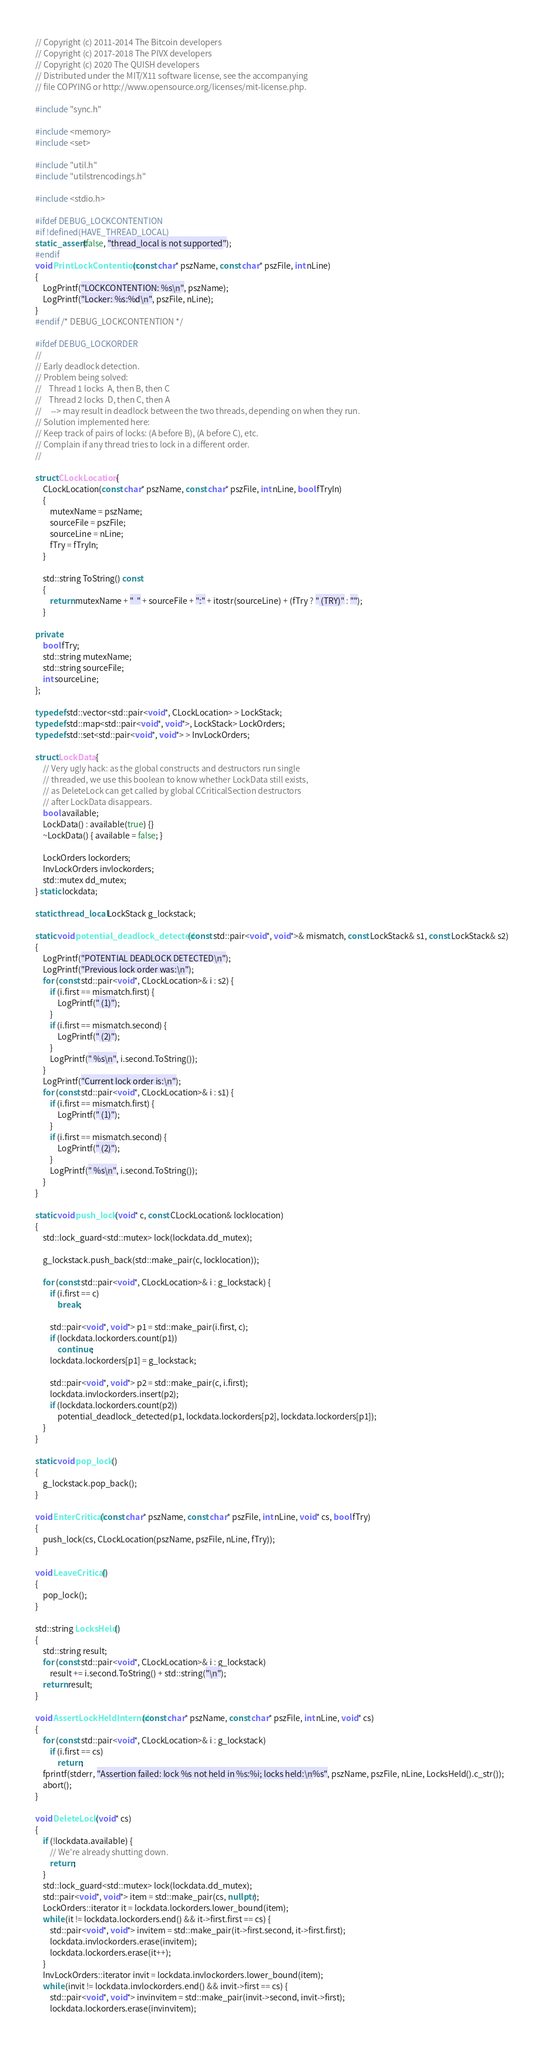<code> <loc_0><loc_0><loc_500><loc_500><_C++_>// Copyright (c) 2011-2014 The Bitcoin developers
// Copyright (c) 2017-2018 The PIVX developers
// Copyright (c) 2020 The QUISH developers
// Distributed under the MIT/X11 software license, see the accompanying
// file COPYING or http://www.opensource.org/licenses/mit-license.php.

#include "sync.h"

#include <memory>
#include <set>

#include "util.h"
#include "utilstrencodings.h"

#include <stdio.h>

#ifdef DEBUG_LOCKCONTENTION
#if !defined(HAVE_THREAD_LOCAL)
static_assert(false, "thread_local is not supported");
#endif
void PrintLockContention(const char* pszName, const char* pszFile, int nLine)
{
    LogPrintf("LOCKCONTENTION: %s\n", pszName);
    LogPrintf("Locker: %s:%d\n", pszFile, nLine);
}
#endif /* DEBUG_LOCKCONTENTION */

#ifdef DEBUG_LOCKORDER
//
// Early deadlock detection.
// Problem being solved:
//    Thread 1 locks  A, then B, then C
//    Thread 2 locks  D, then C, then A
//     --> may result in deadlock between the two threads, depending on when they run.
// Solution implemented here:
// Keep track of pairs of locks: (A before B), (A before C), etc.
// Complain if any thread tries to lock in a different order.
//

struct CLockLocation {
    CLockLocation(const char* pszName, const char* pszFile, int nLine, bool fTryIn)
    {
        mutexName = pszName;
        sourceFile = pszFile;
        sourceLine = nLine;
        fTry = fTryIn;
    }

    std::string ToString() const
    {
        return mutexName + "  " + sourceFile + ":" + itostr(sourceLine) + (fTry ? " (TRY)" : "");
    }

private:
    bool fTry;
    std::string mutexName;
    std::string sourceFile;
    int sourceLine;
};

typedef std::vector<std::pair<void*, CLockLocation> > LockStack;
typedef std::map<std::pair<void*, void*>, LockStack> LockOrders;
typedef std::set<std::pair<void*, void*> > InvLockOrders;

struct LockData {
    // Very ugly hack: as the global constructs and destructors run single
    // threaded, we use this boolean to know whether LockData still exists,
    // as DeleteLock can get called by global CCriticalSection destructors
    // after LockData disappears.
    bool available;
    LockData() : available(true) {}
    ~LockData() { available = false; }

    LockOrders lockorders;
    InvLockOrders invlockorders;
    std::mutex dd_mutex;
} static lockdata;

static thread_local LockStack g_lockstack;

static void potential_deadlock_detected(const std::pair<void*, void*>& mismatch, const LockStack& s1, const LockStack& s2)
{
    LogPrintf("POTENTIAL DEADLOCK DETECTED\n");
    LogPrintf("Previous lock order was:\n");
    for (const std::pair<void*, CLockLocation>& i : s2) {
        if (i.first == mismatch.first) {
            LogPrintf(" (1)");
        }
        if (i.first == mismatch.second) {
            LogPrintf(" (2)");
        }
        LogPrintf(" %s\n", i.second.ToString());
    }
    LogPrintf("Current lock order is:\n");
    for (const std::pair<void*, CLockLocation>& i : s1) {
        if (i.first == mismatch.first) {
            LogPrintf(" (1)");
        }
        if (i.first == mismatch.second) {
            LogPrintf(" (2)");
        }
        LogPrintf(" %s\n", i.second.ToString());
    }
}

static void push_lock(void* c, const CLockLocation& locklocation)
{
    std::lock_guard<std::mutex> lock(lockdata.dd_mutex);

    g_lockstack.push_back(std::make_pair(c, locklocation));

    for (const std::pair<void*, CLockLocation>& i : g_lockstack) {
        if (i.first == c)
            break;

        std::pair<void*, void*> p1 = std::make_pair(i.first, c);
        if (lockdata.lockorders.count(p1))
            continue;
        lockdata.lockorders[p1] = g_lockstack;

        std::pair<void*, void*> p2 = std::make_pair(c, i.first);
        lockdata.invlockorders.insert(p2);
        if (lockdata.lockorders.count(p2))
            potential_deadlock_detected(p1, lockdata.lockorders[p2], lockdata.lockorders[p1]);
    }
}

static void pop_lock()
{
    g_lockstack.pop_back();
}

void EnterCritical(const char* pszName, const char* pszFile, int nLine, void* cs, bool fTry)
{
    push_lock(cs, CLockLocation(pszName, pszFile, nLine, fTry));
}

void LeaveCritical()
{
    pop_lock();
}

std::string LocksHeld()
{
    std::string result;
    for (const std::pair<void*, CLockLocation>& i : g_lockstack)
        result += i.second.ToString() + std::string("\n");
    return result;
}

void AssertLockHeldInternal(const char* pszName, const char* pszFile, int nLine, void* cs)
{
    for (const std::pair<void*, CLockLocation>& i : g_lockstack)
        if (i.first == cs)
            return;
    fprintf(stderr, "Assertion failed: lock %s not held in %s:%i; locks held:\n%s", pszName, pszFile, nLine, LocksHeld().c_str());
    abort();
}

void DeleteLock(void* cs)
{
    if (!lockdata.available) {
        // We're already shutting down.
        return;
    }
    std::lock_guard<std::mutex> lock(lockdata.dd_mutex);
    std::pair<void*, void*> item = std::make_pair(cs, nullptr);
    LockOrders::iterator it = lockdata.lockorders.lower_bound(item);
    while (it != lockdata.lockorders.end() && it->first.first == cs) {
        std::pair<void*, void*> invitem = std::make_pair(it->first.second, it->first.first);
        lockdata.invlockorders.erase(invitem);
        lockdata.lockorders.erase(it++);
    }
    InvLockOrders::iterator invit = lockdata.invlockorders.lower_bound(item);
    while (invit != lockdata.invlockorders.end() && invit->first == cs) {
        std::pair<void*, void*> invinvitem = std::make_pair(invit->second, invit->first);
        lockdata.lockorders.erase(invinvitem);</code> 